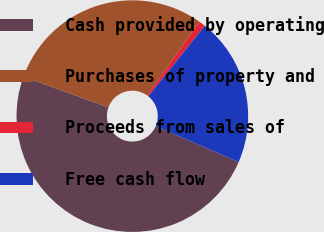Convert chart to OTSL. <chart><loc_0><loc_0><loc_500><loc_500><pie_chart><fcel>Cash provided by operating<fcel>Purchases of property and<fcel>Proceeds from sales of<fcel>Free cash flow<nl><fcel>49.07%<fcel>29.29%<fcel>0.93%<fcel>20.71%<nl></chart> 